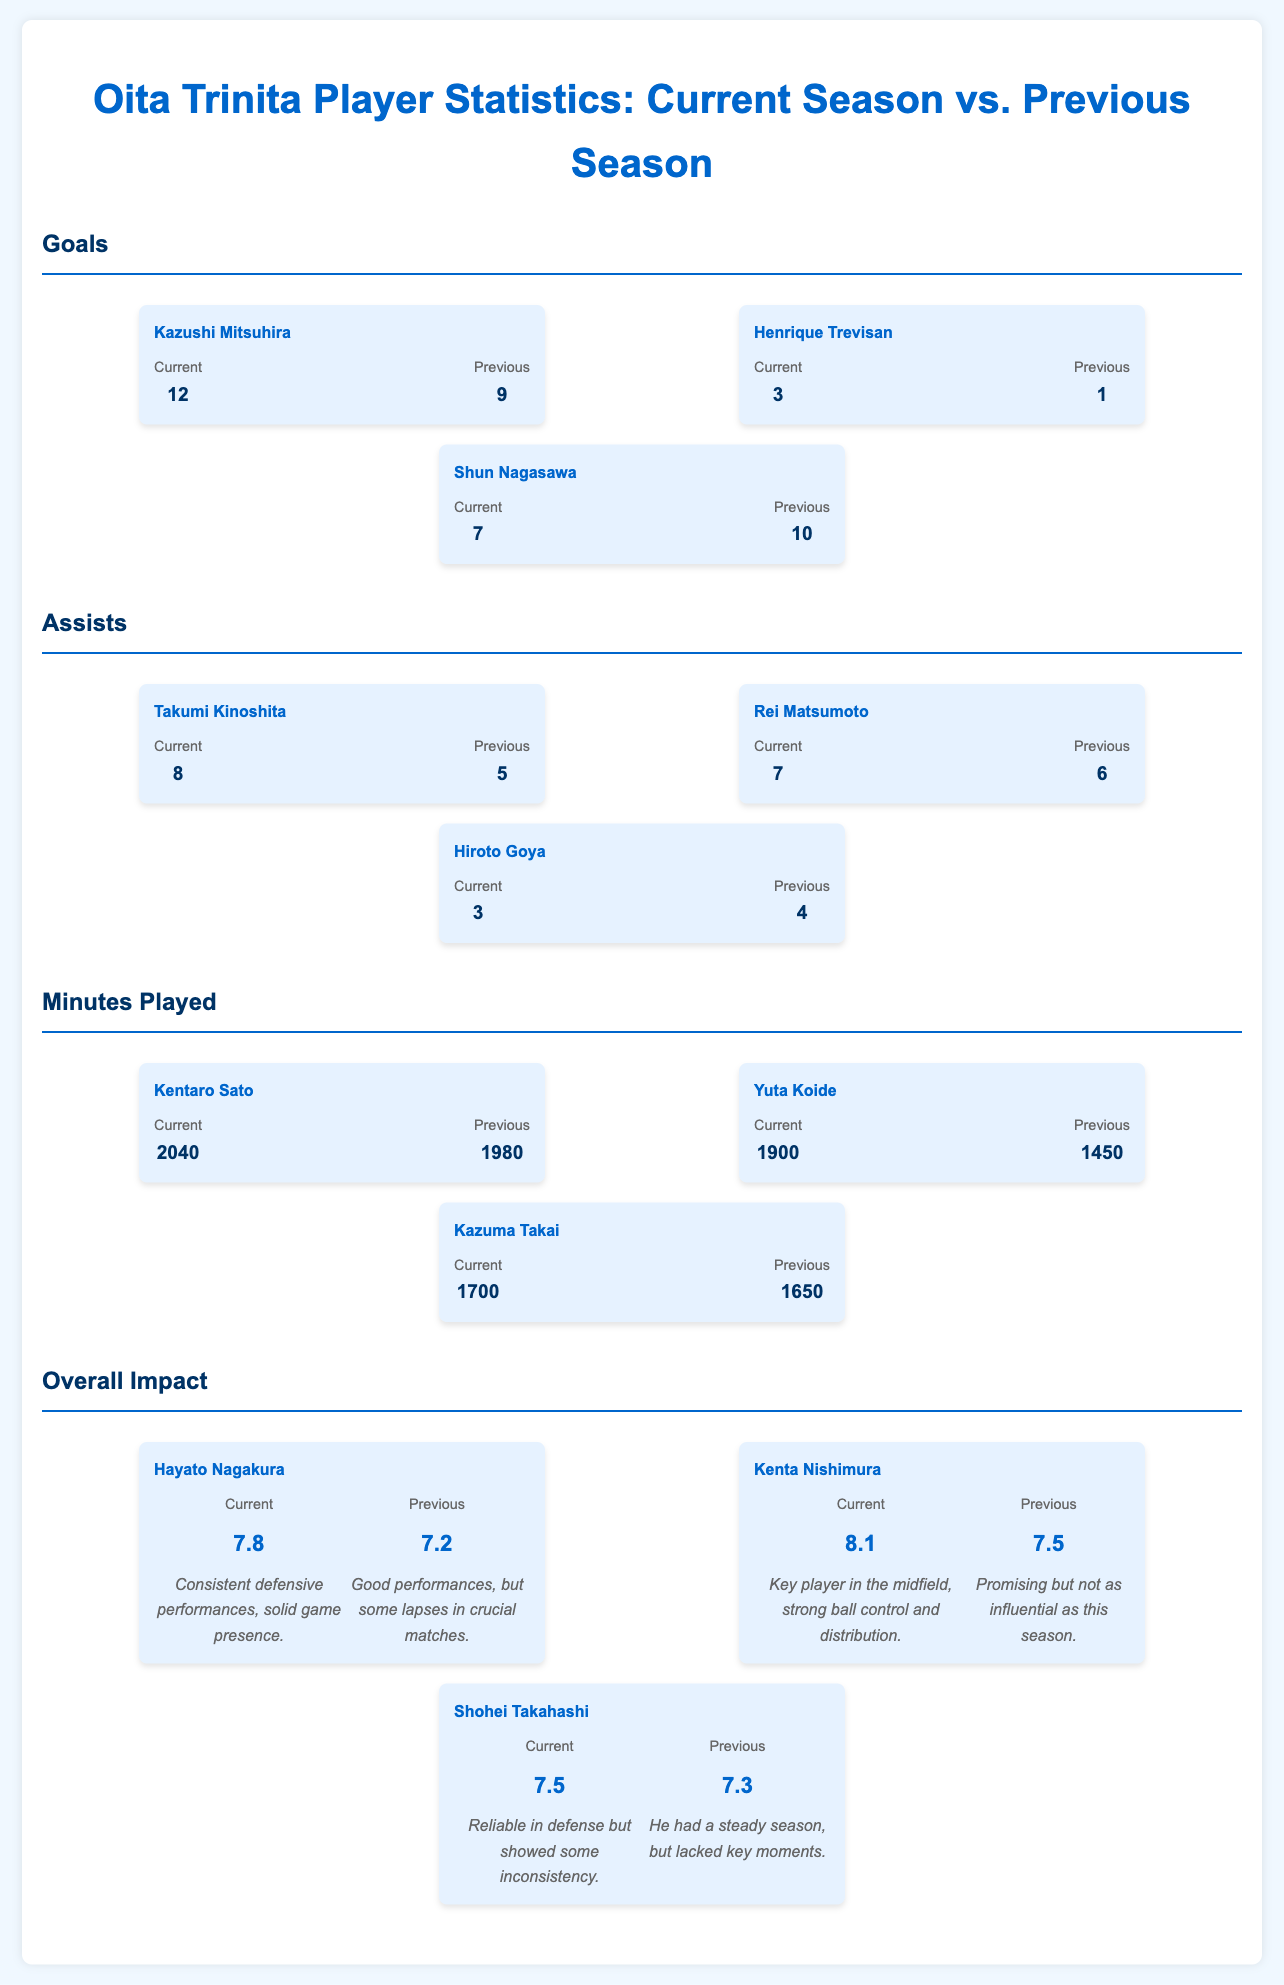What is Kazushi Mitsuhira's goal count for the current season? Kazushi Mitsuhira has scored 12 goals in the current season, as stated in the goals section of the document.
Answer: 12 How many assists did Takumi Kinoshita record last season? Takumi Kinoshita had 5 assists in the previous season, according to the assists section of the document.
Answer: 5 Who had a higher impact rating in the current season, Hayato Nagakura or Kenta Nishimura? Hayato Nagakura's impact rating in the current season is 7.8, while Kenta Nishimura's is 8.1, indicating Nishimura had a higher rating.
Answer: Kenta Nishimura What is the total number of goals scored by Shun Nagasawa this season? Shun Nagasawa has scored 7 goals this season, as shown in the goals section.
Answer: 7 Which player improved their minutes played from the previous season to the current season? Both Kentaro Sato and Yuta Koide have improved their minutes played compared to the last season, with Sato at 2040 and Koide at 1900.
Answer: Kentaro Sato and Yuta Koide How many assists did Hiroto Goya have in the previous season? Hiroto Goya had 4 assists in the previous season, based on the assists section.
Answer: 4 What is the impact rating for Shohei Takahashi in the previous season? Shohei Takahashi's impact rating in the previous season is listed as 7.3 in the overall impact section.
Answer: 7.3 Which player scored more goals in the previous season, Kazushi Mitsuhira or Shun Nagasawa? Kazushi Mitsuhira scored 9 goals while Shun Nagasawa scored 10 goals in the previous season, indicating Nagasawa scored more.
Answer: Shun Nagasawa How did Henrique Trevisan's goal count change from the previous season to the current season? Henrique Trevisan scored 3 goals this season compared to 1 in the previous season, showing an increase in goals.
Answer: Increased 